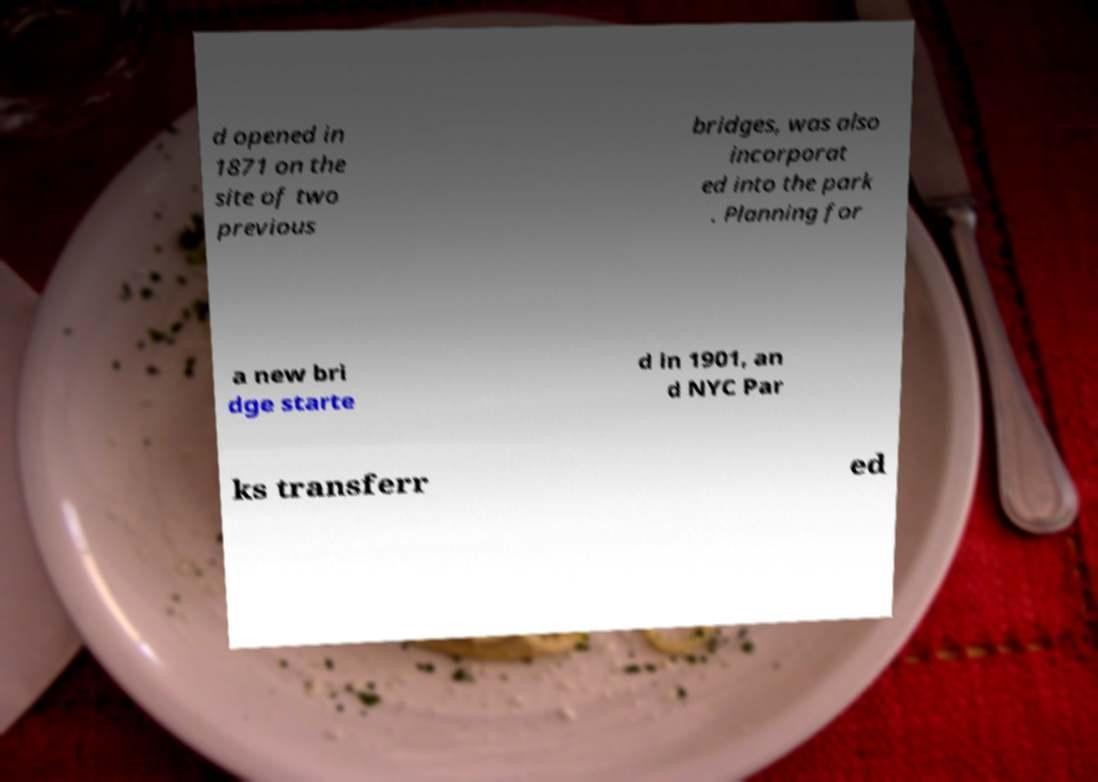I need the written content from this picture converted into text. Can you do that? d opened in 1871 on the site of two previous bridges, was also incorporat ed into the park . Planning for a new bri dge starte d in 1901, an d NYC Par ks transferr ed 